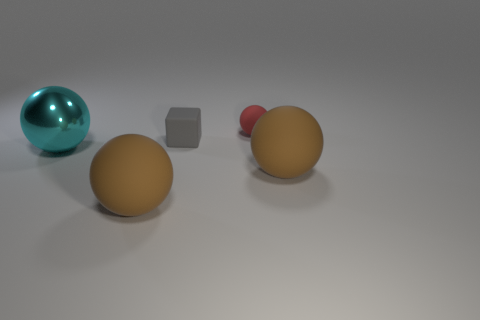Is the number of large brown objects in front of the red rubber ball less than the number of gray things? While there are two large brown objects visible in the image, there is only one small gray object. So no, the number of large brown objects in front of the red rubber ball is not less than the number of gray things. 